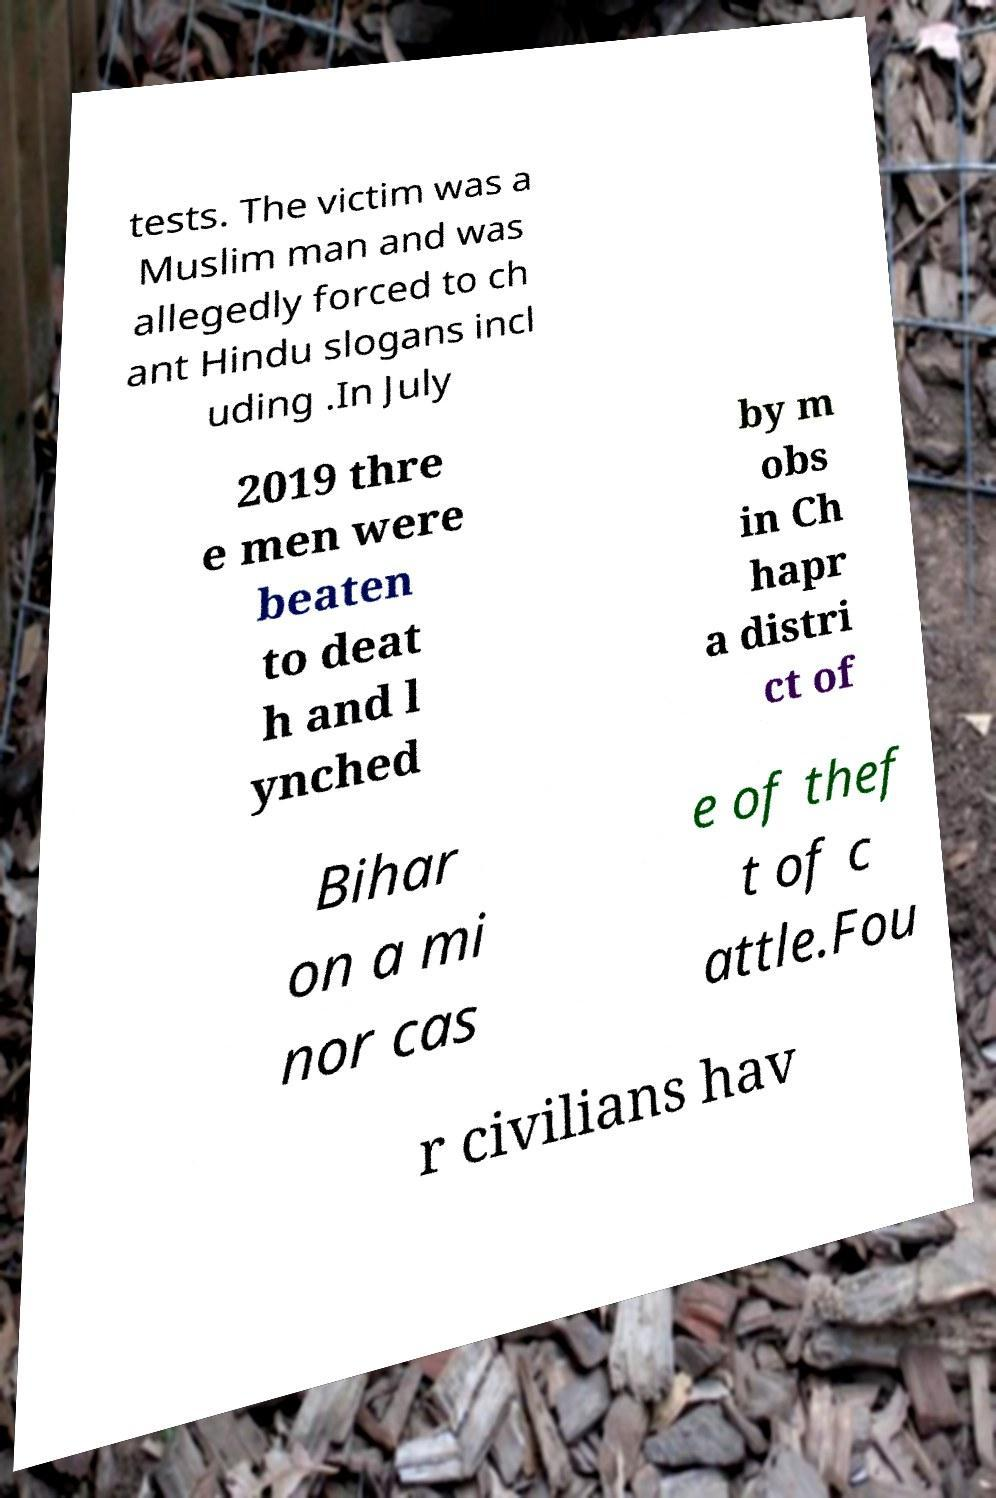Could you assist in decoding the text presented in this image and type it out clearly? tests. The victim was a Muslim man and was allegedly forced to ch ant Hindu slogans incl uding .In July 2019 thre e men were beaten to deat h and l ynched by m obs in Ch hapr a distri ct of Bihar on a mi nor cas e of thef t of c attle.Fou r civilians hav 